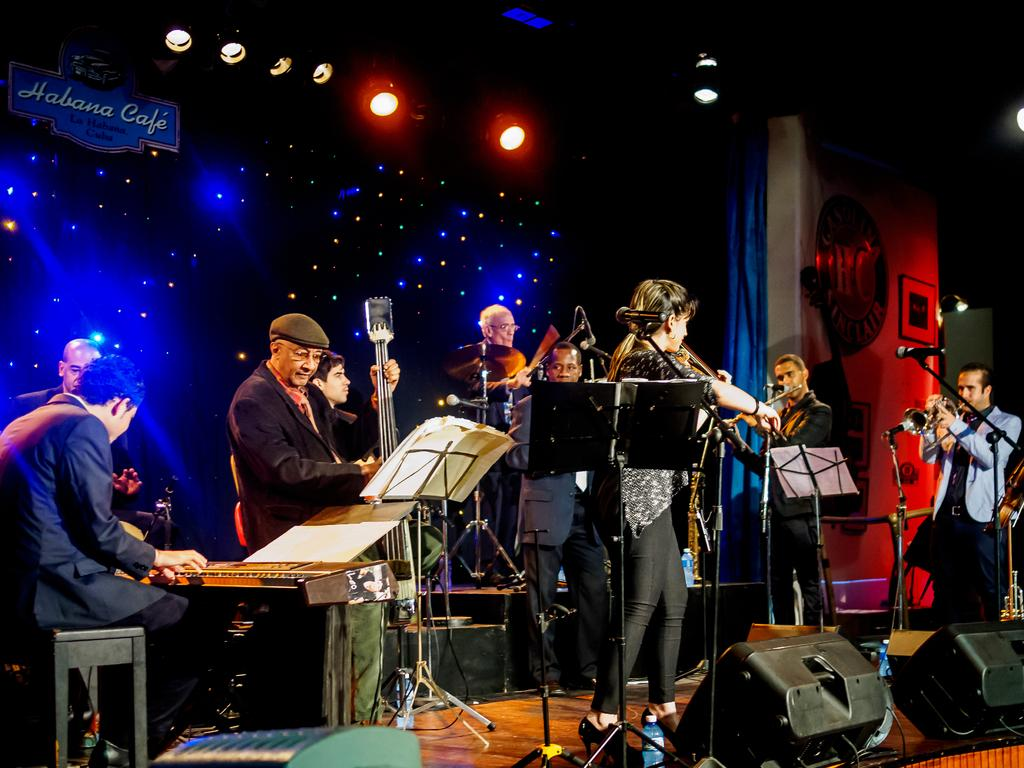What are the people in the image doing? The people in the image are standing. What objects can be seen that are related to music? There are musical instruments in the image. What can be seen that provides illumination? There are lights in the image. What objects are present that amplify sound? There are speakers in the image. How many cakes are being served on gold plates in the image? There are no cakes or gold plates present in the image. 